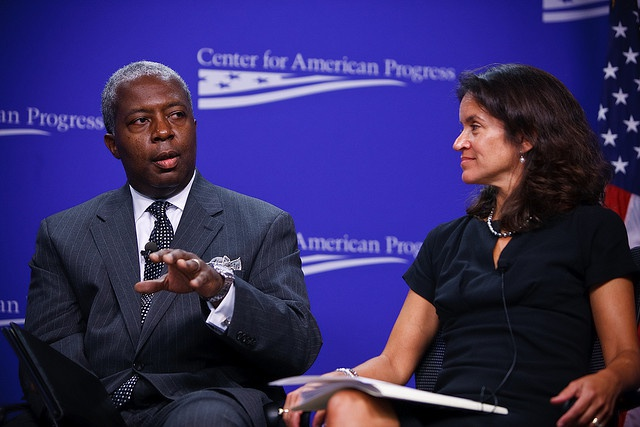Describe the objects in this image and their specific colors. I can see people in navy, black, maroon, brown, and salmon tones, people in navy, black, gray, and maroon tones, laptop in navy, black, gray, and darkblue tones, and tie in navy, black, gray, and darkgray tones in this image. 